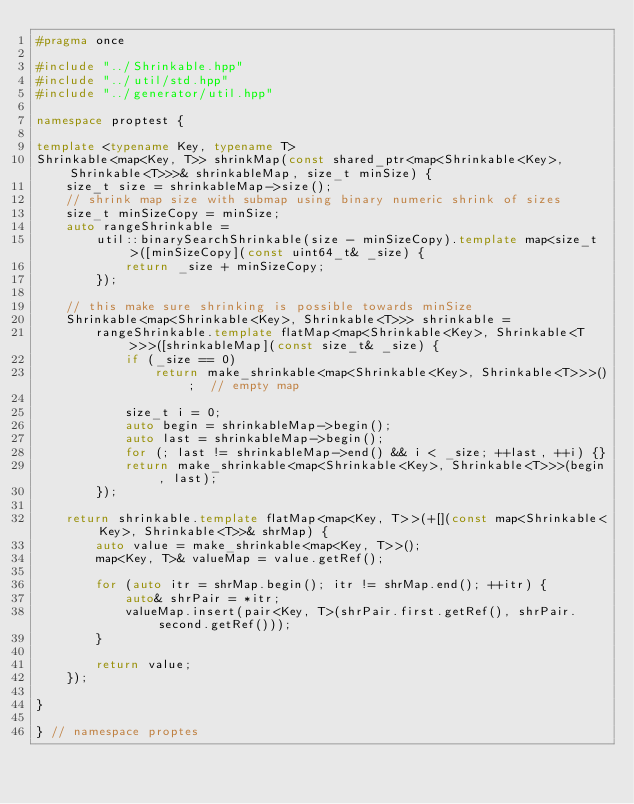Convert code to text. <code><loc_0><loc_0><loc_500><loc_500><_C++_>#pragma once

#include "../Shrinkable.hpp"
#include "../util/std.hpp"
#include "../generator/util.hpp"

namespace proptest {

template <typename Key, typename T>
Shrinkable<map<Key, T>> shrinkMap(const shared_ptr<map<Shrinkable<Key>, Shrinkable<T>>>& shrinkableMap, size_t minSize) {
    size_t size = shrinkableMap->size();
    // shrink map size with submap using binary numeric shrink of sizes
    size_t minSizeCopy = minSize;
    auto rangeShrinkable =
        util::binarySearchShrinkable(size - minSizeCopy).template map<size_t>([minSizeCopy](const uint64_t& _size) {
            return _size + minSizeCopy;
        });

    // this make sure shrinking is possible towards minSize
    Shrinkable<map<Shrinkable<Key>, Shrinkable<T>>> shrinkable =
        rangeShrinkable.template flatMap<map<Shrinkable<Key>, Shrinkable<T>>>([shrinkableMap](const size_t& _size) {
            if (_size == 0)
                return make_shrinkable<map<Shrinkable<Key>, Shrinkable<T>>>();  // empty map

            size_t i = 0;
            auto begin = shrinkableMap->begin();
            auto last = shrinkableMap->begin();
            for (; last != shrinkableMap->end() && i < _size; ++last, ++i) {}
            return make_shrinkable<map<Shrinkable<Key>, Shrinkable<T>>>(begin, last);
        });

    return shrinkable.template flatMap<map<Key, T>>(+[](const map<Shrinkable<Key>, Shrinkable<T>>& shrMap) {
        auto value = make_shrinkable<map<Key, T>>();
        map<Key, T>& valueMap = value.getRef();

        for (auto itr = shrMap.begin(); itr != shrMap.end(); ++itr) {
            auto& shrPair = *itr;
            valueMap.insert(pair<Key, T>(shrPair.first.getRef(), shrPair.second.getRef()));
        }

        return value;
    });

}

} // namespace proptes
</code> 